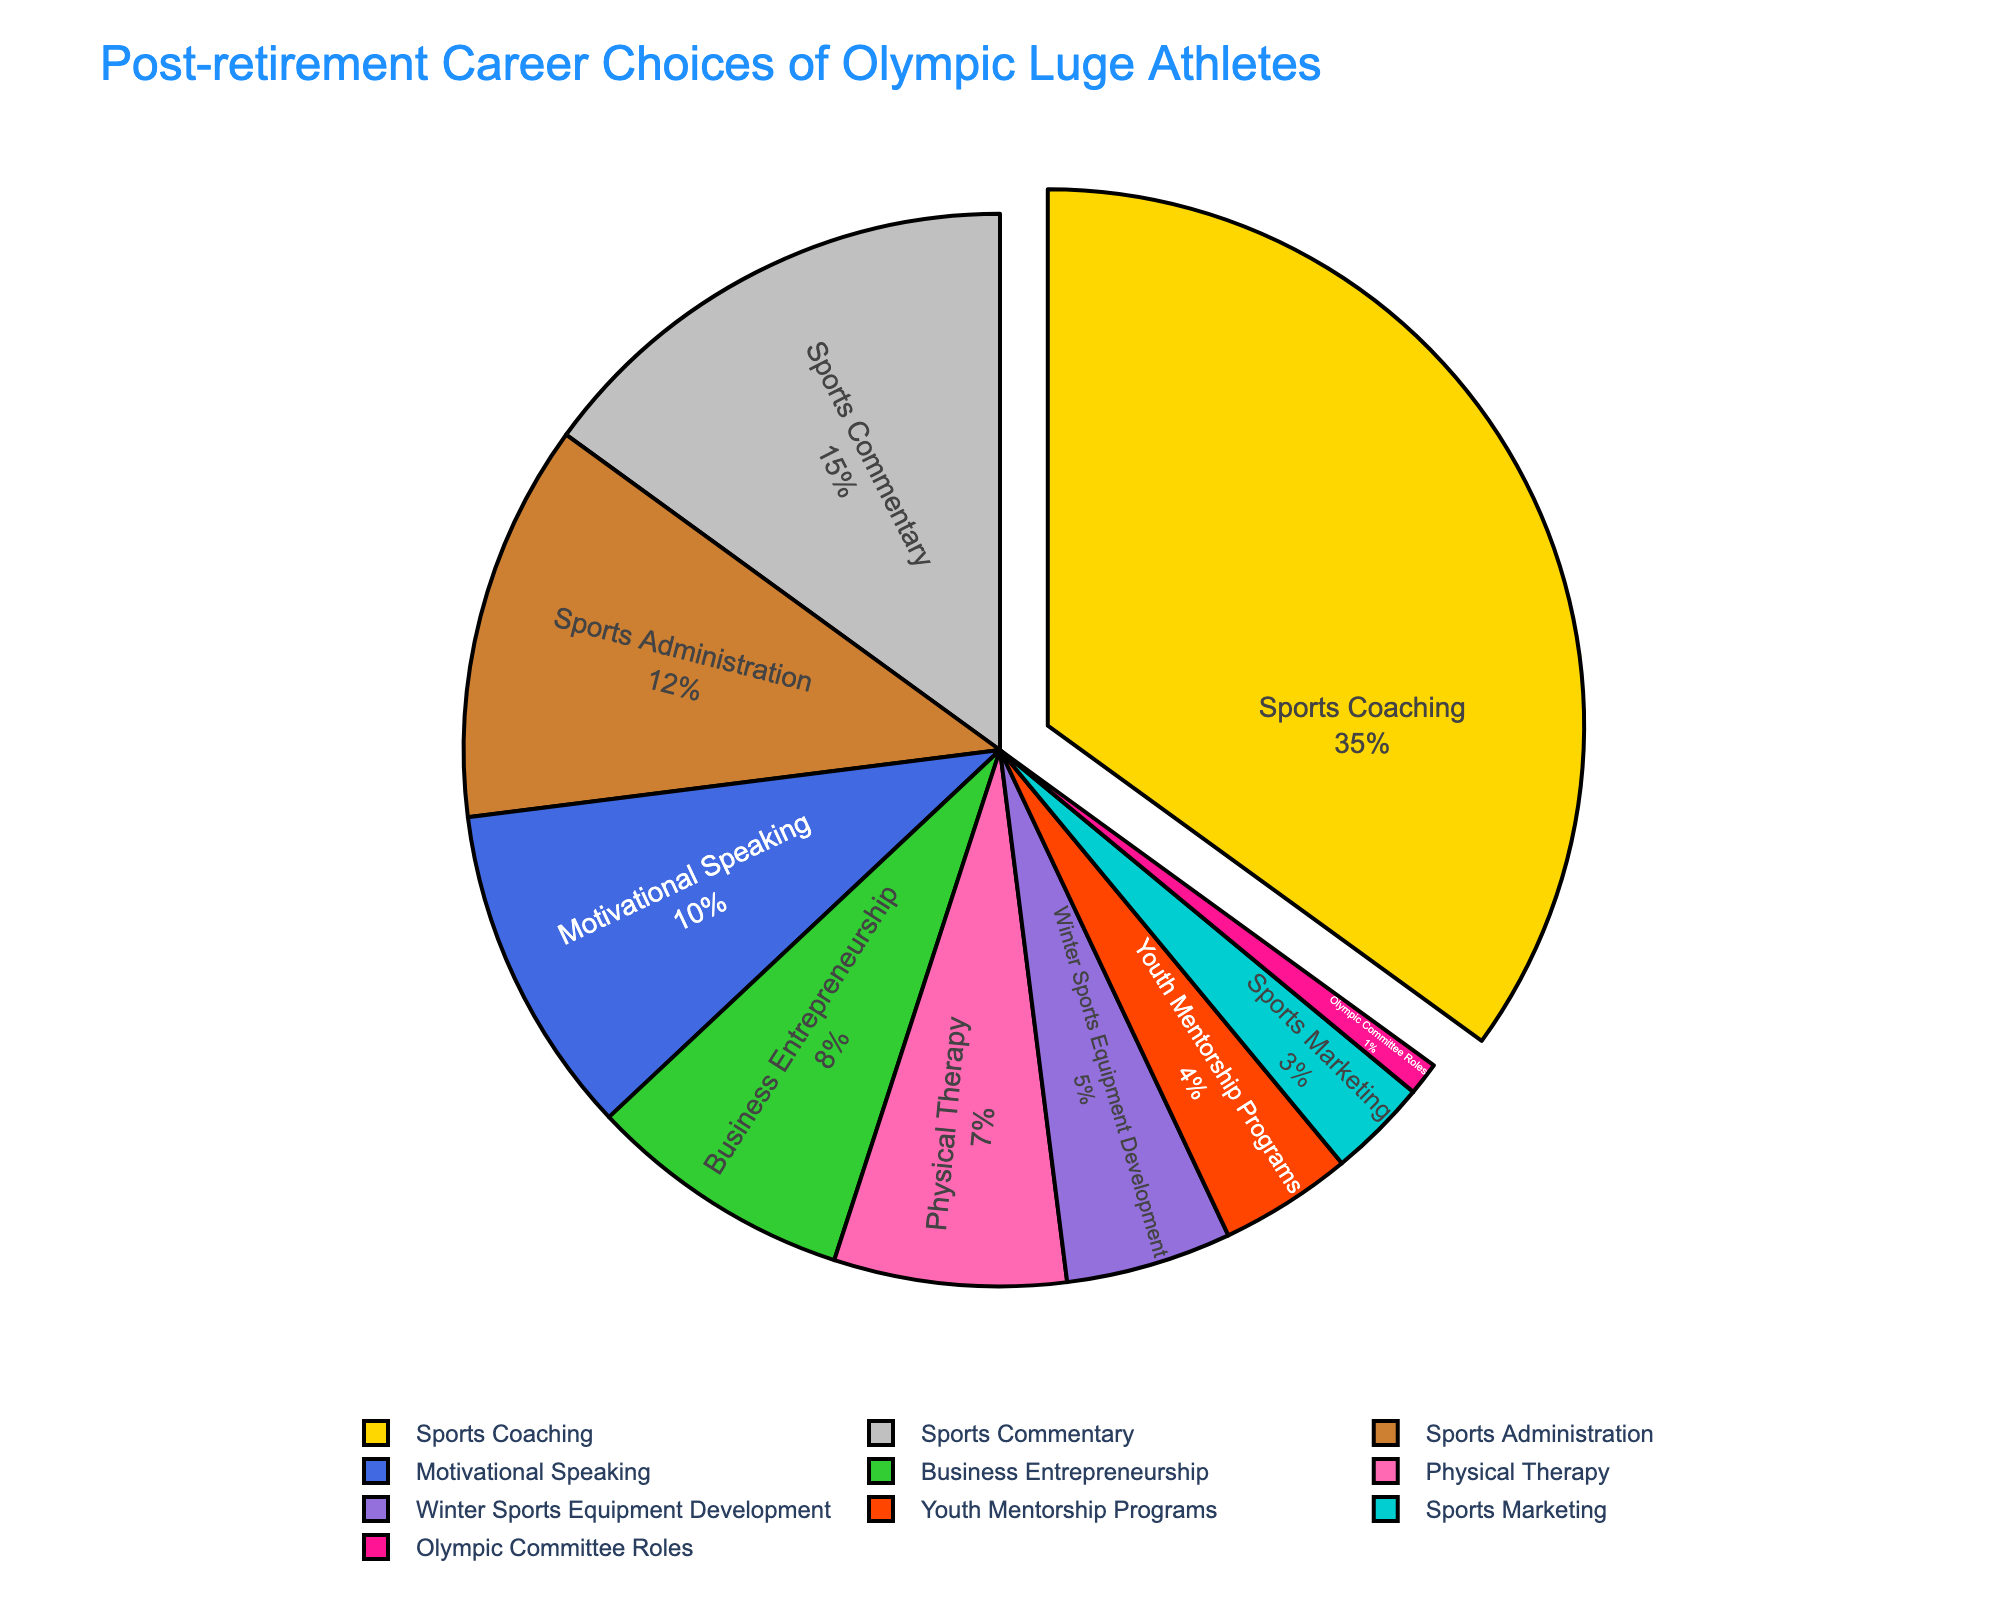Which career has the highest percentage among retired Olympic luge athletes? By referring to the figure, it's clear that the career with the largest slice of the pie chart represents Sports Coaching.
Answer: Sports Coaching What is the combined percentage for Motivational Speaking and Youth Mentorship Programs? Motivational Speaking has 10% and Youth Mentorship Programs have 4%. Adding these together results in 10 + 4 = 14%.
Answer: 14% How much greater is the percentage of Sports Coaching compared to Business Entrepreneurship? Sports Coaching accounts for 35% while Business Entrepreneurship accounts for 8%. The difference is 35 - 8 = 27%.
Answer: 27% Which two career options collectively make up more than half of the chart? Sports Coaching is 35% and Sports Commentary is 15%. Collectively they make up 35 + 15 = 50%, which is exactly half. Therefore, checking another pair, Sports Coaching at 35% and Sports Administration at 12% collectively is 35 + 12 = 47%, still not more than half. Therefore, considering top three, Sports Coaching, Sports Commentary, and Sports Administration, their total is 35 + 15 + 12 = 62%, which is more than half.
Answer: Sports Coaching and any of Sports Commentary or Sports Administration Among the careers listed, which one has the lowest representation? The smallest slice of the pie chart represents Olympic Committee Roles.
Answer: Olympic Committee Roles What is the percentage difference between Physical Therapy and Winter Sports Equipment Development? Physical Therapy has a percentage of 7%, while Winter Sports Equipment Development has 5%. The percentage difference is 7 - 5 = 2%.
Answer: 2% Do Sports Administration and Business Entrepreneurship combined exceed the percentage of Sports Coaching? Sports Administration has 12% and Business Entrepreneurship has 8%. Combined, they total 12 + 8 = 20%. Sports Coaching stands at 35%, thus 20% does not exceed 35%.
Answer: No What percentage of athletes went into a sports-related career (combining all related categories)? Summing up the percentages for Sports Coaching (35%), Sports Commentary (15%), Sports Administration (12%), and various other sports-related roles, we will get: 35 + 15 + 12 + 5 + 3 + 1 = 71%.
Answer: 71% If you combine categories involving direct athlete interaction (Coaching, Physical Therapy, Mentorship), what percentage do you get? The related percentages are Coaching (35%), Physical Therapy (7%), and Youth Mentorship Programs (4%). Adding these together: 35 + 7 + 4 = 46%.
Answer: 46% Between Winter Sports Equipment Development and Sports Marketing, which career post-retirement is chosen by a higher percentage of athletes? Winter Sports Equipment Development stands at 5% while Sports Marketing is 3%. Hence, Winter Sports Equipment Development is chosen by a higher percentage.
Answer: Winter Sports Equipment Development 